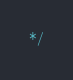Convert code to text. <code><loc_0><loc_0><loc_500><loc_500><_CSS_>*/</code> 